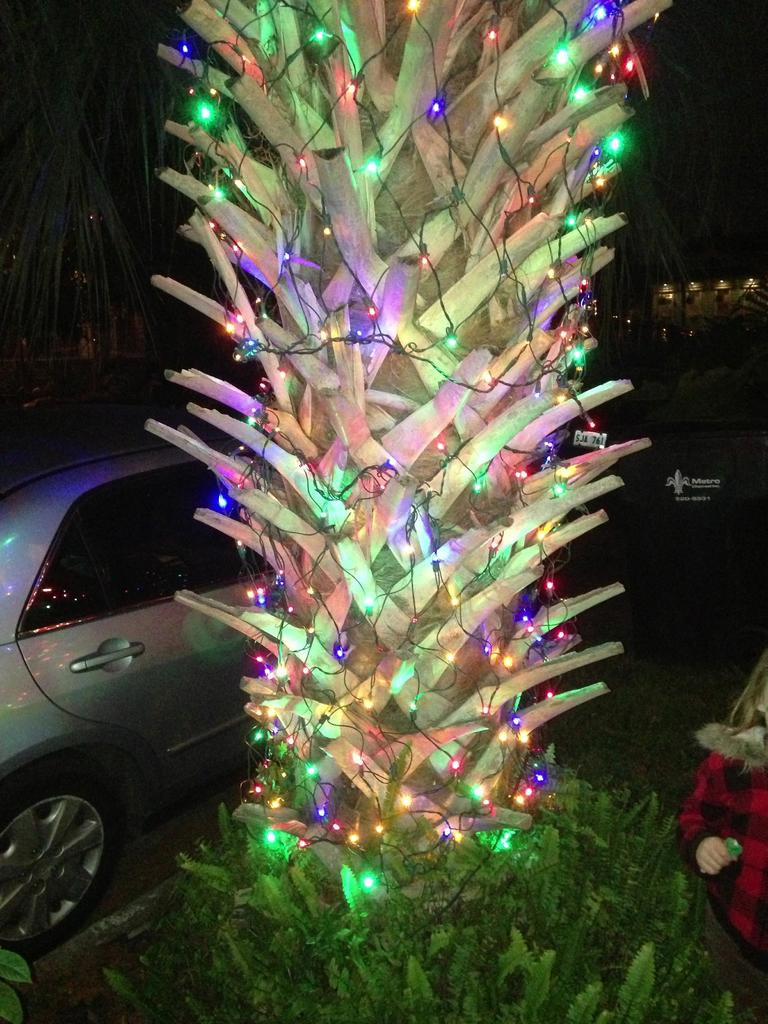What is the main object in the image? There is a tree in the image. How is the tree decorated? The tree is decorated with colorful lights. What can be seen in the background of the image? There is a vehicle and a person in the background of the image. What is the color of the background in the image? The background of the image is dark in color. How many dimes are placed on the branches of the tree in the image? There are no dimes present on the tree in the image. What type of comfort can be found in the image? The image does not depict any form of comfort; it features a tree decorated with lights and a background with a vehicle and a person. 